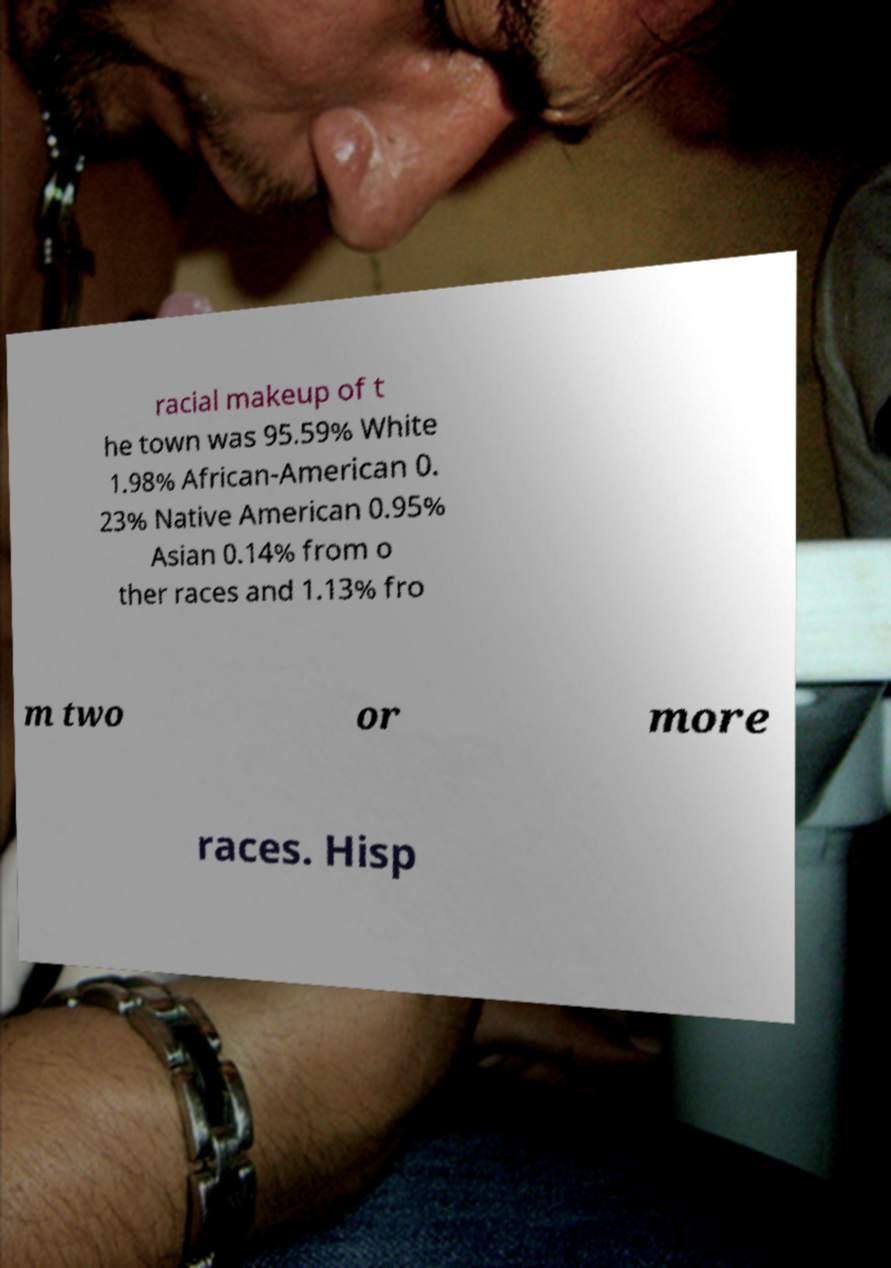What messages or text are displayed in this image? I need them in a readable, typed format. racial makeup of t he town was 95.59% White 1.98% African-American 0. 23% Native American 0.95% Asian 0.14% from o ther races and 1.13% fro m two or more races. Hisp 